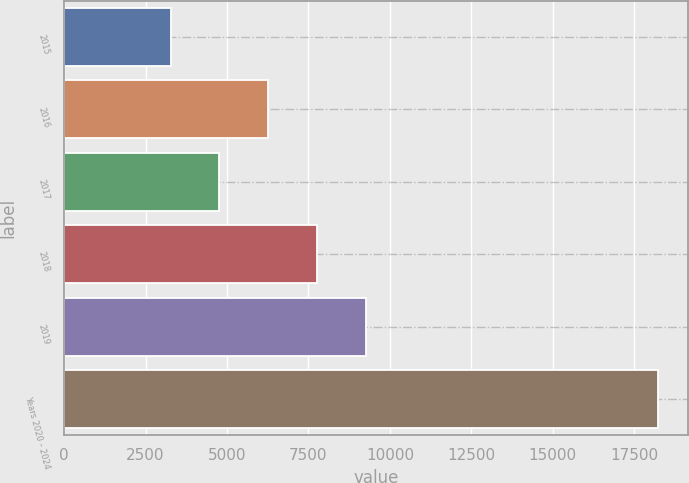<chart> <loc_0><loc_0><loc_500><loc_500><bar_chart><fcel>2015<fcel>2016<fcel>2017<fcel>2018<fcel>2019<fcel>Years 2020 - 2024<nl><fcel>3268<fcel>6260.2<fcel>4764.1<fcel>7756.3<fcel>9252.4<fcel>18229<nl></chart> 